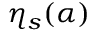Convert formula to latex. <formula><loc_0><loc_0><loc_500><loc_500>\eta _ { s } ( \alpha )</formula> 